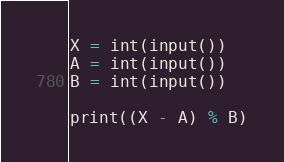Convert code to text. <code><loc_0><loc_0><loc_500><loc_500><_Python_>X = int(input())
A = int(input())
B = int(input())

print((X - A) % B)</code> 